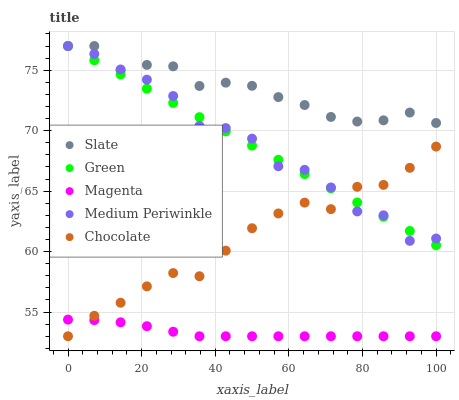Does Magenta have the minimum area under the curve?
Answer yes or no. Yes. Does Slate have the maximum area under the curve?
Answer yes or no. Yes. Does Green have the minimum area under the curve?
Answer yes or no. No. Does Green have the maximum area under the curve?
Answer yes or no. No. Is Green the smoothest?
Answer yes or no. Yes. Is Medium Periwinkle the roughest?
Answer yes or no. Yes. Is Slate the smoothest?
Answer yes or no. No. Is Slate the roughest?
Answer yes or no. No. Does Magenta have the lowest value?
Answer yes or no. Yes. Does Green have the lowest value?
Answer yes or no. No. Does Green have the highest value?
Answer yes or no. Yes. Does Magenta have the highest value?
Answer yes or no. No. Is Magenta less than Medium Periwinkle?
Answer yes or no. Yes. Is Slate greater than Chocolate?
Answer yes or no. Yes. Does Magenta intersect Chocolate?
Answer yes or no. Yes. Is Magenta less than Chocolate?
Answer yes or no. No. Is Magenta greater than Chocolate?
Answer yes or no. No. Does Magenta intersect Medium Periwinkle?
Answer yes or no. No. 